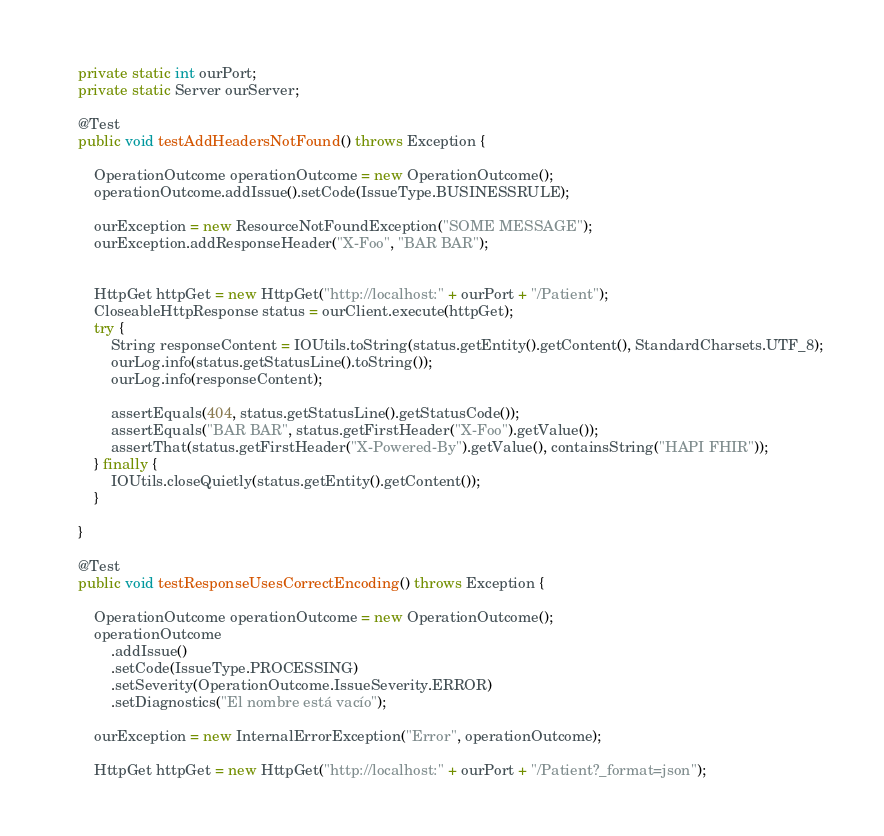Convert code to text. <code><loc_0><loc_0><loc_500><loc_500><_Java_>	private static int ourPort;
	private static Server ourServer;

	@Test
	public void testAddHeadersNotFound() throws Exception {

		OperationOutcome operationOutcome = new OperationOutcome();
		operationOutcome.addIssue().setCode(IssueType.BUSINESSRULE);

		ourException = new ResourceNotFoundException("SOME MESSAGE");
		ourException.addResponseHeader("X-Foo", "BAR BAR");


		HttpGet httpGet = new HttpGet("http://localhost:" + ourPort + "/Patient");
		CloseableHttpResponse status = ourClient.execute(httpGet);
		try {
			String responseContent = IOUtils.toString(status.getEntity().getContent(), StandardCharsets.UTF_8);
			ourLog.info(status.getStatusLine().toString());
			ourLog.info(responseContent);

			assertEquals(404, status.getStatusLine().getStatusCode());
			assertEquals("BAR BAR", status.getFirstHeader("X-Foo").getValue());
			assertThat(status.getFirstHeader("X-Powered-By").getValue(), containsString("HAPI FHIR"));
		} finally {
			IOUtils.closeQuietly(status.getEntity().getContent());
		}

	}

	@Test
	public void testResponseUsesCorrectEncoding() throws Exception {

		OperationOutcome operationOutcome = new OperationOutcome();
		operationOutcome
			.addIssue()
			.setCode(IssueType.PROCESSING)
			.setSeverity(OperationOutcome.IssueSeverity.ERROR)
			.setDiagnostics("El nombre está vacío");

		ourException = new InternalErrorException("Error", operationOutcome);

		HttpGet httpGet = new HttpGet("http://localhost:" + ourPort + "/Patient?_format=json");</code> 